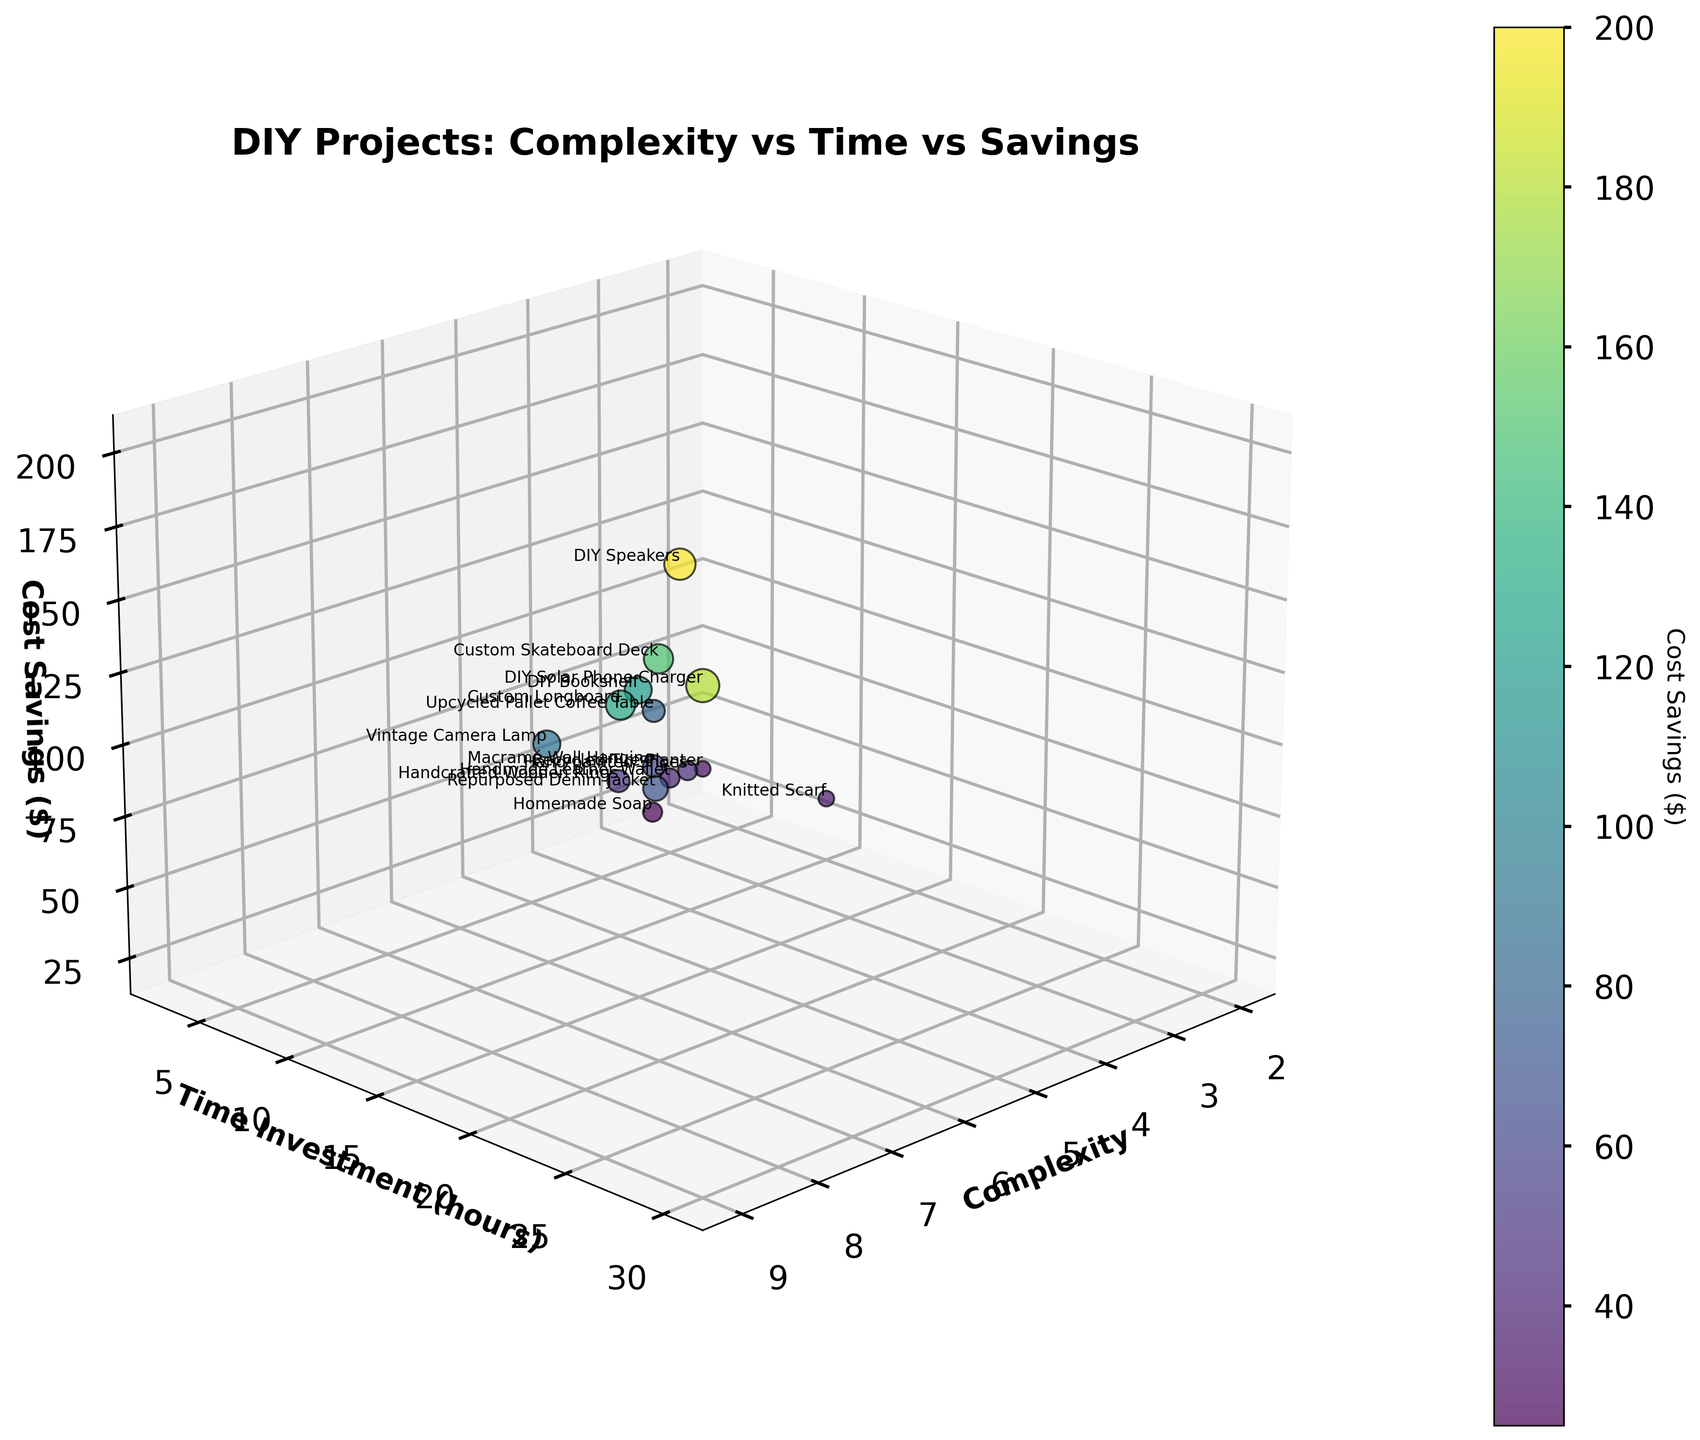What is the title of the plot? The title is usually located at the top of the plot and summarizes what the figure is about.
Answer: DIY Projects: Complexity vs Time vs Savings Which axis represents "Cost Savings"? The z-axis, which is labeled "Cost Savings ($)," represents cost savings. It is the third axis in a 3D plot.
Answer: The z-axis What project has the highest cost savings? Look for the data point positioned highest on the cost savings axis (z-axis).
Answer: DIY Speakers How many projects have a complexity level of 4? Count the number of data points that align with the complexity axis value of 4.
Answer: 3 projects What is the relationship between time investment and cost savings for the project "Custom Longboard"? Locate the "Custom Longboard" label in the plot, then determine its coordinates on the time investment (y-axis) and cost savings (z-axis) axes.
Answer: 18 hours and $130 Which project has the lowest time investment and what are its cost savings? Find the data point that is closest to the origin on the time investment axis (y-axis) and then check its position along the cost savings axis (z-axis).
Answer: Recycled Tire Planter with $30 cost savings Are projects with higher complexity generally correlated with higher cost savings? Observe the trend among the data points. Check if higher complexity levels are mostly paired with higher positions on the cost savings axis (z-axis).
Answer: Yes, higher complexity often leads to higher cost savings What is the average time investment for projects with complexity levels of 6 and above? Extract the time investment values of projects with a complexity of 6 or more, sum them, and divide by the number of such projects.
Answer: (15+10+20+25+18+30)/6 = 118/6 = 19.67 hours Which project has a higher cost savings, "Handcrafted Wooden Rings" or "Macramé Wall Hanging"? Compare the positions of these two projects along the cost savings axis (z-axis).
Answer: Handcrafted Wooden Rings What range of complexity and time investment does the "DIY Solar Phone Charger" fall into? Identify the position of the DIY Solar Phone Charger and read its values from the complexity and time investment axes.
Answer: Complexity 9, Time Investment 30 hours 